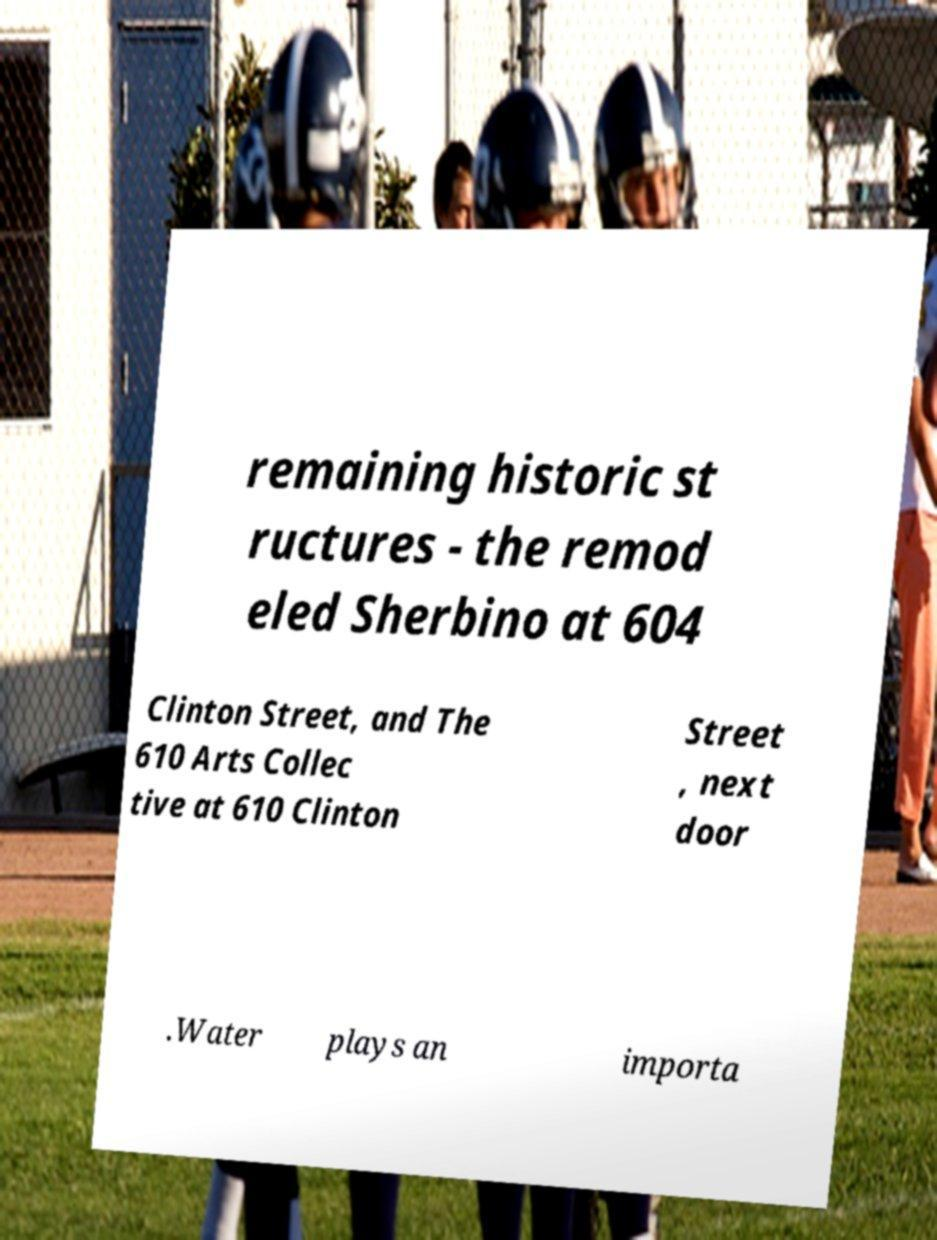Can you read and provide the text displayed in the image?This photo seems to have some interesting text. Can you extract and type it out for me? remaining historic st ructures - the remod eled Sherbino at 604 Clinton Street, and The 610 Arts Collec tive at 610 Clinton Street , next door .Water plays an importa 